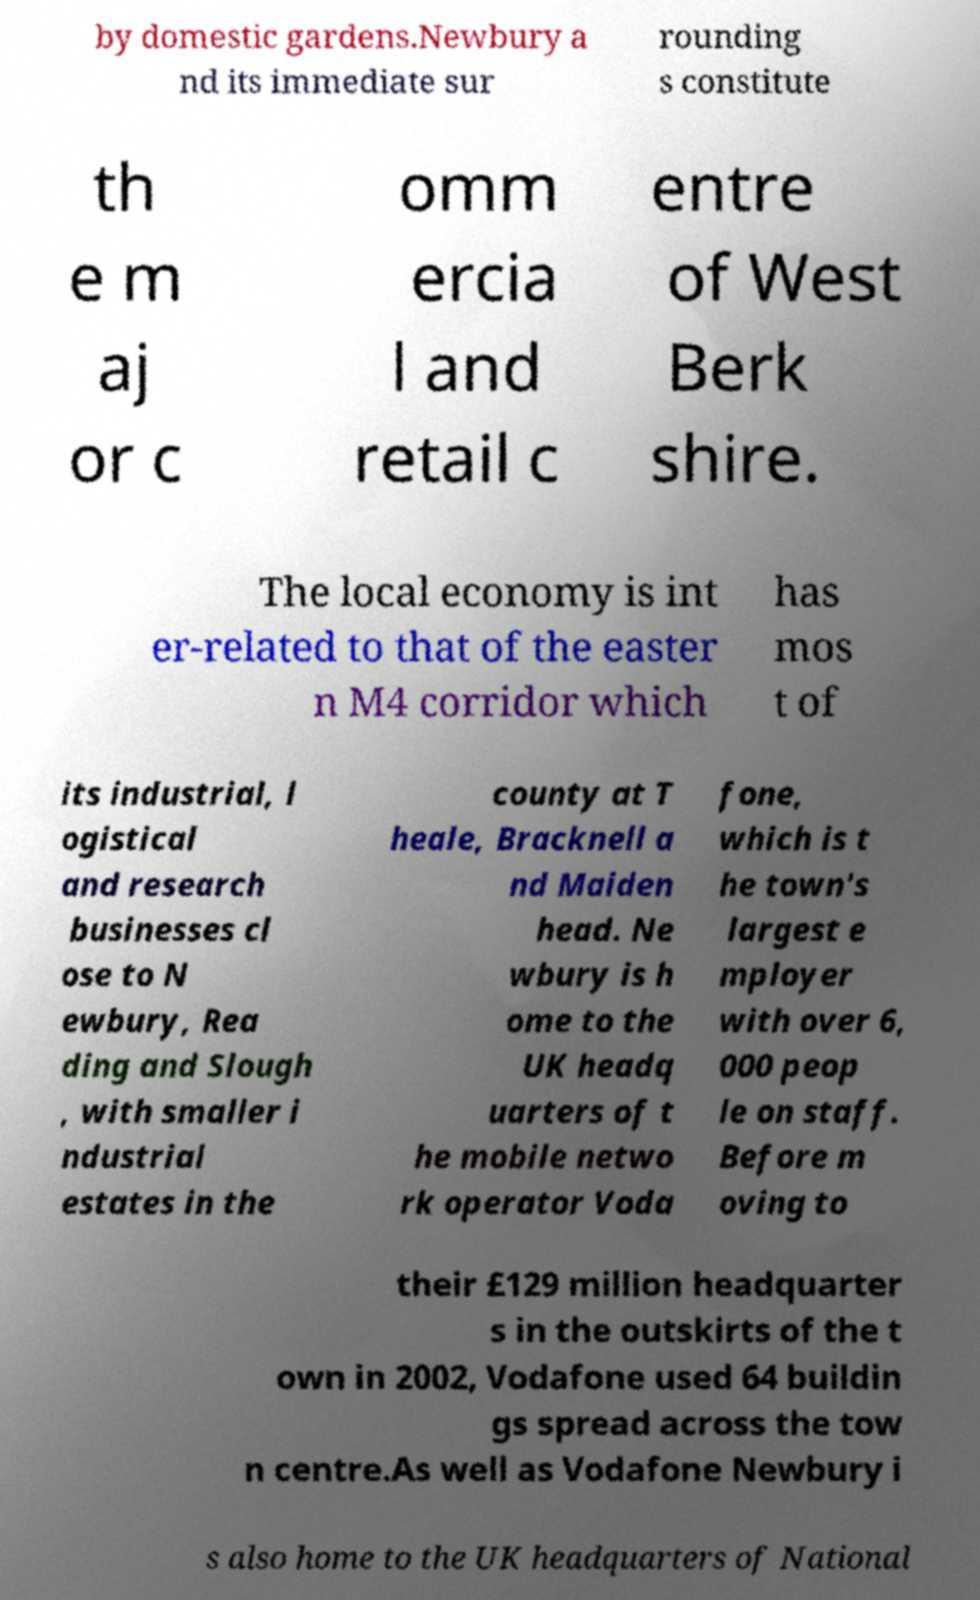What messages or text are displayed in this image? I need them in a readable, typed format. by domestic gardens.Newbury a nd its immediate sur rounding s constitute th e m aj or c omm ercia l and retail c entre of West Berk shire. The local economy is int er-related to that of the easter n M4 corridor which has mos t of its industrial, l ogistical and research businesses cl ose to N ewbury, Rea ding and Slough , with smaller i ndustrial estates in the county at T heale, Bracknell a nd Maiden head. Ne wbury is h ome to the UK headq uarters of t he mobile netwo rk operator Voda fone, which is t he town's largest e mployer with over 6, 000 peop le on staff. Before m oving to their £129 million headquarter s in the outskirts of the t own in 2002, Vodafone used 64 buildin gs spread across the tow n centre.As well as Vodafone Newbury i s also home to the UK headquarters of National 